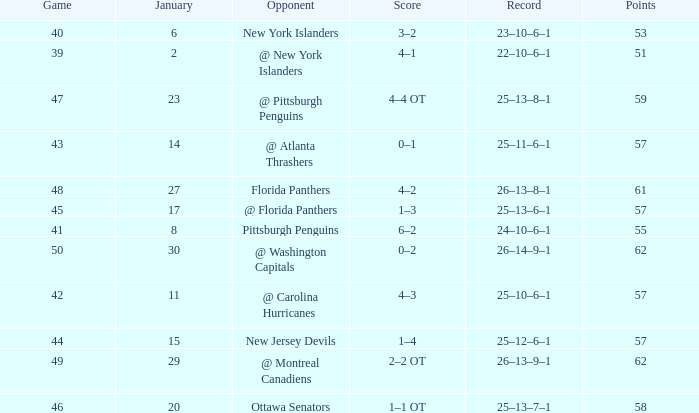What is the average for january with points of 51 2.0. 